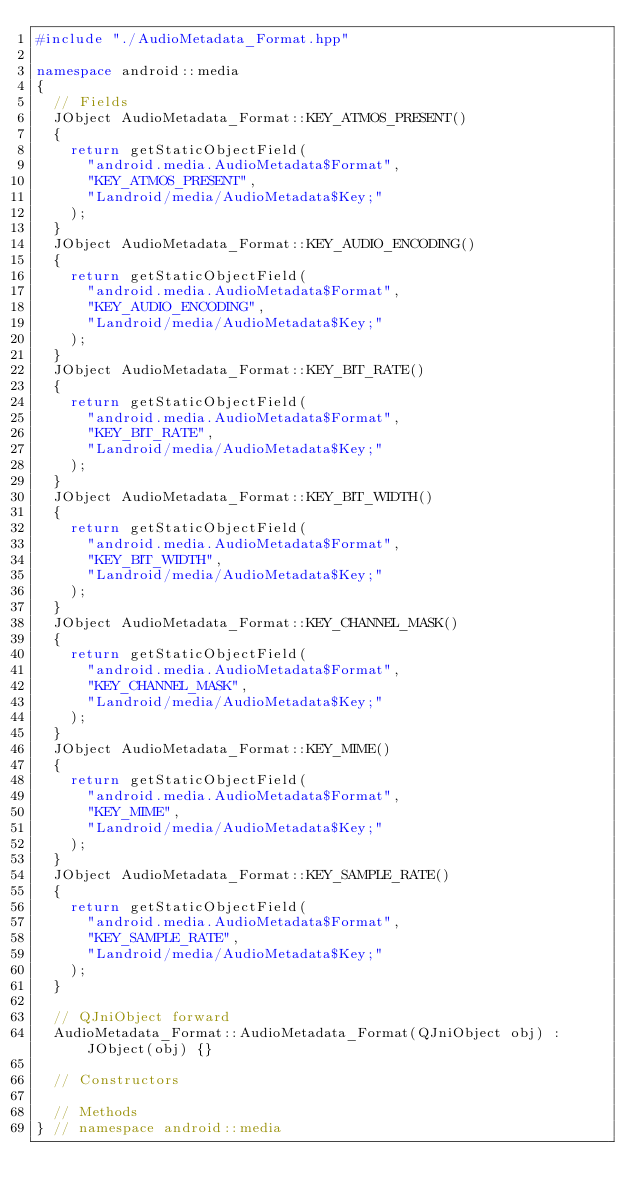<code> <loc_0><loc_0><loc_500><loc_500><_C++_>#include "./AudioMetadata_Format.hpp"

namespace android::media
{
	// Fields
	JObject AudioMetadata_Format::KEY_ATMOS_PRESENT()
	{
		return getStaticObjectField(
			"android.media.AudioMetadata$Format",
			"KEY_ATMOS_PRESENT",
			"Landroid/media/AudioMetadata$Key;"
		);
	}
	JObject AudioMetadata_Format::KEY_AUDIO_ENCODING()
	{
		return getStaticObjectField(
			"android.media.AudioMetadata$Format",
			"KEY_AUDIO_ENCODING",
			"Landroid/media/AudioMetadata$Key;"
		);
	}
	JObject AudioMetadata_Format::KEY_BIT_RATE()
	{
		return getStaticObjectField(
			"android.media.AudioMetadata$Format",
			"KEY_BIT_RATE",
			"Landroid/media/AudioMetadata$Key;"
		);
	}
	JObject AudioMetadata_Format::KEY_BIT_WIDTH()
	{
		return getStaticObjectField(
			"android.media.AudioMetadata$Format",
			"KEY_BIT_WIDTH",
			"Landroid/media/AudioMetadata$Key;"
		);
	}
	JObject AudioMetadata_Format::KEY_CHANNEL_MASK()
	{
		return getStaticObjectField(
			"android.media.AudioMetadata$Format",
			"KEY_CHANNEL_MASK",
			"Landroid/media/AudioMetadata$Key;"
		);
	}
	JObject AudioMetadata_Format::KEY_MIME()
	{
		return getStaticObjectField(
			"android.media.AudioMetadata$Format",
			"KEY_MIME",
			"Landroid/media/AudioMetadata$Key;"
		);
	}
	JObject AudioMetadata_Format::KEY_SAMPLE_RATE()
	{
		return getStaticObjectField(
			"android.media.AudioMetadata$Format",
			"KEY_SAMPLE_RATE",
			"Landroid/media/AudioMetadata$Key;"
		);
	}
	
	// QJniObject forward
	AudioMetadata_Format::AudioMetadata_Format(QJniObject obj) : JObject(obj) {}
	
	// Constructors
	
	// Methods
} // namespace android::media

</code> 